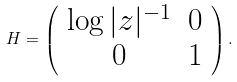Convert formula to latex. <formula><loc_0><loc_0><loc_500><loc_500>H = \left ( \begin{array} { c c } \log | z | ^ { - 1 } & 0 \\ 0 & 1 \\ \end{array} \right ) .</formula> 